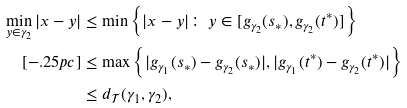Convert formula to latex. <formula><loc_0><loc_0><loc_500><loc_500>\min _ { y \in \gamma _ { 2 } } | x - y | & \leq \min \left \{ | x - y | \colon \, y \in [ g _ { \gamma _ { 2 } } ( s _ { * } ) , g _ { \gamma _ { 2 } } ( t ^ { * } ) ] \right \} \\ [ - . 2 5 p c ] & \leq \max \left \{ | g _ { \gamma _ { 1 } } ( s _ { * } ) - g _ { \gamma _ { 2 } } ( s _ { * } ) | , | g _ { \gamma _ { 1 } } ( t ^ { * } ) - g _ { \gamma _ { 2 } } ( t ^ { * } ) | \right \} \\ & \leq d _ { \mathcal { T } } ( \gamma _ { 1 } , \gamma _ { 2 } ) ,</formula> 